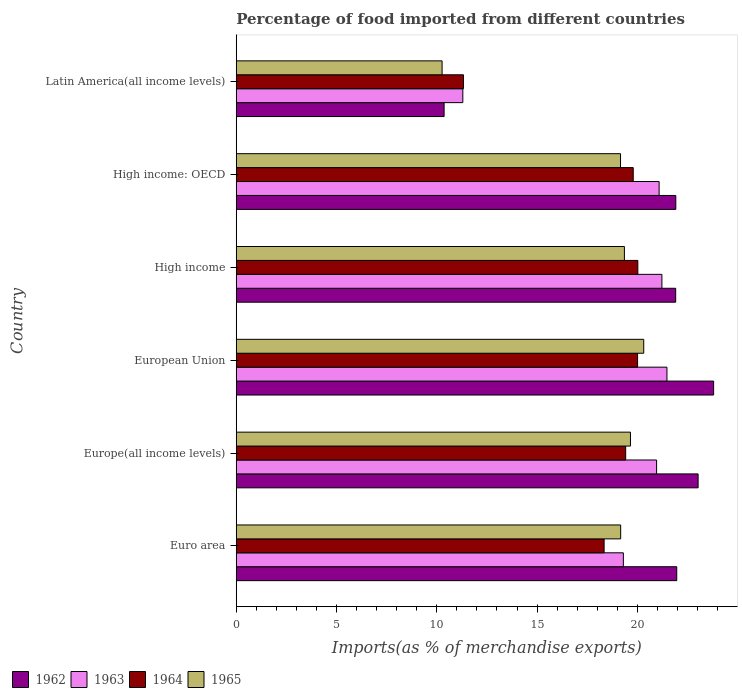How many different coloured bars are there?
Keep it short and to the point. 4. Are the number of bars per tick equal to the number of legend labels?
Make the answer very short. Yes. How many bars are there on the 2nd tick from the top?
Provide a succinct answer. 4. What is the label of the 3rd group of bars from the top?
Your response must be concise. High income. What is the percentage of imports to different countries in 1964 in Euro area?
Offer a very short reply. 18.34. Across all countries, what is the maximum percentage of imports to different countries in 1964?
Your answer should be compact. 20.02. Across all countries, what is the minimum percentage of imports to different countries in 1962?
Your answer should be very brief. 10.36. In which country was the percentage of imports to different countries in 1964 minimum?
Your answer should be very brief. Latin America(all income levels). What is the total percentage of imports to different countries in 1962 in the graph?
Provide a succinct answer. 123. What is the difference between the percentage of imports to different countries in 1965 in Europe(all income levels) and that in High income?
Your answer should be very brief. 0.3. What is the difference between the percentage of imports to different countries in 1963 in Euro area and the percentage of imports to different countries in 1965 in European Union?
Provide a short and direct response. -1.02. What is the average percentage of imports to different countries in 1964 per country?
Ensure brevity in your answer.  18.15. What is the difference between the percentage of imports to different countries in 1964 and percentage of imports to different countries in 1962 in European Union?
Provide a succinct answer. -3.79. What is the ratio of the percentage of imports to different countries in 1962 in High income to that in High income: OECD?
Offer a very short reply. 1. Is the percentage of imports to different countries in 1963 in Europe(all income levels) less than that in High income?
Offer a terse response. Yes. Is the difference between the percentage of imports to different countries in 1964 in Europe(all income levels) and European Union greater than the difference between the percentage of imports to different countries in 1962 in Europe(all income levels) and European Union?
Provide a short and direct response. Yes. What is the difference between the highest and the second highest percentage of imports to different countries in 1962?
Offer a very short reply. 0.77. What is the difference between the highest and the lowest percentage of imports to different countries in 1963?
Provide a short and direct response. 10.18. In how many countries, is the percentage of imports to different countries in 1965 greater than the average percentage of imports to different countries in 1965 taken over all countries?
Ensure brevity in your answer.  5. What does the 1st bar from the top in High income: OECD represents?
Your response must be concise. 1965. Are all the bars in the graph horizontal?
Give a very brief answer. Yes. What is the difference between two consecutive major ticks on the X-axis?
Offer a very short reply. 5. Where does the legend appear in the graph?
Provide a succinct answer. Bottom left. What is the title of the graph?
Your response must be concise. Percentage of food imported from different countries. What is the label or title of the X-axis?
Make the answer very short. Imports(as % of merchandise exports). What is the Imports(as % of merchandise exports) of 1962 in Euro area?
Your answer should be compact. 21.97. What is the Imports(as % of merchandise exports) of 1963 in Euro area?
Give a very brief answer. 19.3. What is the Imports(as % of merchandise exports) of 1964 in Euro area?
Give a very brief answer. 18.34. What is the Imports(as % of merchandise exports) in 1965 in Euro area?
Your response must be concise. 19.17. What is the Imports(as % of merchandise exports) in 1962 in Europe(all income levels)?
Offer a very short reply. 23.03. What is the Imports(as % of merchandise exports) in 1963 in Europe(all income levels)?
Give a very brief answer. 20.96. What is the Imports(as % of merchandise exports) of 1964 in Europe(all income levels)?
Offer a terse response. 19.42. What is the Imports(as % of merchandise exports) in 1965 in Europe(all income levels)?
Offer a terse response. 19.66. What is the Imports(as % of merchandise exports) in 1962 in European Union?
Ensure brevity in your answer.  23.8. What is the Imports(as % of merchandise exports) in 1963 in European Union?
Give a very brief answer. 21.48. What is the Imports(as % of merchandise exports) in 1964 in European Union?
Provide a short and direct response. 20.01. What is the Imports(as % of merchandise exports) of 1965 in European Union?
Provide a succinct answer. 20.32. What is the Imports(as % of merchandise exports) of 1962 in High income?
Provide a succinct answer. 21.91. What is the Imports(as % of merchandise exports) in 1963 in High income?
Offer a very short reply. 21.23. What is the Imports(as % of merchandise exports) of 1964 in High income?
Keep it short and to the point. 20.02. What is the Imports(as % of merchandise exports) in 1965 in High income?
Offer a terse response. 19.36. What is the Imports(as % of merchandise exports) of 1962 in High income: OECD?
Offer a terse response. 21.92. What is the Imports(as % of merchandise exports) in 1963 in High income: OECD?
Your answer should be very brief. 21.09. What is the Imports(as % of merchandise exports) of 1964 in High income: OECD?
Provide a short and direct response. 19.8. What is the Imports(as % of merchandise exports) in 1965 in High income: OECD?
Make the answer very short. 19.16. What is the Imports(as % of merchandise exports) in 1962 in Latin America(all income levels)?
Provide a succinct answer. 10.36. What is the Imports(as % of merchandise exports) in 1963 in Latin America(all income levels)?
Your answer should be very brief. 11.3. What is the Imports(as % of merchandise exports) of 1964 in Latin America(all income levels)?
Keep it short and to the point. 11.33. What is the Imports(as % of merchandise exports) in 1965 in Latin America(all income levels)?
Offer a very short reply. 10.26. Across all countries, what is the maximum Imports(as % of merchandise exports) of 1962?
Provide a short and direct response. 23.8. Across all countries, what is the maximum Imports(as % of merchandise exports) of 1963?
Ensure brevity in your answer.  21.48. Across all countries, what is the maximum Imports(as % of merchandise exports) of 1964?
Give a very brief answer. 20.02. Across all countries, what is the maximum Imports(as % of merchandise exports) in 1965?
Keep it short and to the point. 20.32. Across all countries, what is the minimum Imports(as % of merchandise exports) of 1962?
Provide a succinct answer. 10.36. Across all countries, what is the minimum Imports(as % of merchandise exports) in 1963?
Offer a terse response. 11.3. Across all countries, what is the minimum Imports(as % of merchandise exports) in 1964?
Offer a terse response. 11.33. Across all countries, what is the minimum Imports(as % of merchandise exports) of 1965?
Offer a very short reply. 10.26. What is the total Imports(as % of merchandise exports) in 1962 in the graph?
Provide a short and direct response. 123. What is the total Imports(as % of merchandise exports) in 1963 in the graph?
Make the answer very short. 115.35. What is the total Imports(as % of merchandise exports) of 1964 in the graph?
Provide a short and direct response. 108.92. What is the total Imports(as % of merchandise exports) of 1965 in the graph?
Offer a terse response. 107.93. What is the difference between the Imports(as % of merchandise exports) of 1962 in Euro area and that in Europe(all income levels)?
Your answer should be very brief. -1.07. What is the difference between the Imports(as % of merchandise exports) of 1963 in Euro area and that in Europe(all income levels)?
Make the answer very short. -1.66. What is the difference between the Imports(as % of merchandise exports) in 1964 in Euro area and that in Europe(all income levels)?
Make the answer very short. -1.08. What is the difference between the Imports(as % of merchandise exports) of 1965 in Euro area and that in Europe(all income levels)?
Your response must be concise. -0.49. What is the difference between the Imports(as % of merchandise exports) in 1962 in Euro area and that in European Union?
Your response must be concise. -1.84. What is the difference between the Imports(as % of merchandise exports) in 1963 in Euro area and that in European Union?
Offer a terse response. -2.17. What is the difference between the Imports(as % of merchandise exports) of 1964 in Euro area and that in European Union?
Your answer should be very brief. -1.67. What is the difference between the Imports(as % of merchandise exports) of 1965 in Euro area and that in European Union?
Your answer should be compact. -1.15. What is the difference between the Imports(as % of merchandise exports) of 1962 in Euro area and that in High income?
Provide a short and direct response. 0.05. What is the difference between the Imports(as % of merchandise exports) in 1963 in Euro area and that in High income?
Keep it short and to the point. -1.92. What is the difference between the Imports(as % of merchandise exports) of 1964 in Euro area and that in High income?
Offer a very short reply. -1.68. What is the difference between the Imports(as % of merchandise exports) in 1965 in Euro area and that in High income?
Offer a very short reply. -0.19. What is the difference between the Imports(as % of merchandise exports) in 1962 in Euro area and that in High income: OECD?
Offer a very short reply. 0.05. What is the difference between the Imports(as % of merchandise exports) in 1963 in Euro area and that in High income: OECD?
Give a very brief answer. -1.78. What is the difference between the Imports(as % of merchandise exports) of 1964 in Euro area and that in High income: OECD?
Offer a terse response. -1.45. What is the difference between the Imports(as % of merchandise exports) in 1965 in Euro area and that in High income: OECD?
Your response must be concise. 0.01. What is the difference between the Imports(as % of merchandise exports) of 1962 in Euro area and that in Latin America(all income levels)?
Offer a terse response. 11.6. What is the difference between the Imports(as % of merchandise exports) in 1963 in Euro area and that in Latin America(all income levels)?
Your answer should be very brief. 8. What is the difference between the Imports(as % of merchandise exports) of 1964 in Euro area and that in Latin America(all income levels)?
Provide a short and direct response. 7.01. What is the difference between the Imports(as % of merchandise exports) of 1965 in Euro area and that in Latin America(all income levels)?
Your answer should be very brief. 8.9. What is the difference between the Imports(as % of merchandise exports) of 1962 in Europe(all income levels) and that in European Union?
Your answer should be compact. -0.77. What is the difference between the Imports(as % of merchandise exports) in 1963 in Europe(all income levels) and that in European Union?
Provide a short and direct response. -0.52. What is the difference between the Imports(as % of merchandise exports) of 1964 in Europe(all income levels) and that in European Union?
Give a very brief answer. -0.59. What is the difference between the Imports(as % of merchandise exports) in 1965 in Europe(all income levels) and that in European Union?
Offer a terse response. -0.66. What is the difference between the Imports(as % of merchandise exports) in 1962 in Europe(all income levels) and that in High income?
Your response must be concise. 1.12. What is the difference between the Imports(as % of merchandise exports) in 1963 in Europe(all income levels) and that in High income?
Offer a terse response. -0.27. What is the difference between the Imports(as % of merchandise exports) in 1964 in Europe(all income levels) and that in High income?
Make the answer very short. -0.61. What is the difference between the Imports(as % of merchandise exports) of 1965 in Europe(all income levels) and that in High income?
Your response must be concise. 0.3. What is the difference between the Imports(as % of merchandise exports) of 1962 in Europe(all income levels) and that in High income: OECD?
Offer a terse response. 1.11. What is the difference between the Imports(as % of merchandise exports) in 1963 in Europe(all income levels) and that in High income: OECD?
Provide a succinct answer. -0.13. What is the difference between the Imports(as % of merchandise exports) of 1964 in Europe(all income levels) and that in High income: OECD?
Provide a succinct answer. -0.38. What is the difference between the Imports(as % of merchandise exports) of 1965 in Europe(all income levels) and that in High income: OECD?
Provide a succinct answer. 0.5. What is the difference between the Imports(as % of merchandise exports) of 1962 in Europe(all income levels) and that in Latin America(all income levels)?
Your answer should be very brief. 12.67. What is the difference between the Imports(as % of merchandise exports) in 1963 in Europe(all income levels) and that in Latin America(all income levels)?
Provide a succinct answer. 9.66. What is the difference between the Imports(as % of merchandise exports) in 1964 in Europe(all income levels) and that in Latin America(all income levels)?
Give a very brief answer. 8.09. What is the difference between the Imports(as % of merchandise exports) in 1965 in Europe(all income levels) and that in Latin America(all income levels)?
Keep it short and to the point. 9.39. What is the difference between the Imports(as % of merchandise exports) of 1962 in European Union and that in High income?
Ensure brevity in your answer.  1.89. What is the difference between the Imports(as % of merchandise exports) in 1963 in European Union and that in High income?
Your response must be concise. 0.25. What is the difference between the Imports(as % of merchandise exports) of 1964 in European Union and that in High income?
Make the answer very short. -0.01. What is the difference between the Imports(as % of merchandise exports) in 1965 in European Union and that in High income?
Your answer should be very brief. 0.96. What is the difference between the Imports(as % of merchandise exports) in 1962 in European Union and that in High income: OECD?
Give a very brief answer. 1.89. What is the difference between the Imports(as % of merchandise exports) in 1963 in European Union and that in High income: OECD?
Ensure brevity in your answer.  0.39. What is the difference between the Imports(as % of merchandise exports) in 1964 in European Union and that in High income: OECD?
Give a very brief answer. 0.22. What is the difference between the Imports(as % of merchandise exports) of 1965 in European Union and that in High income: OECD?
Keep it short and to the point. 1.16. What is the difference between the Imports(as % of merchandise exports) of 1962 in European Union and that in Latin America(all income levels)?
Your answer should be very brief. 13.44. What is the difference between the Imports(as % of merchandise exports) of 1963 in European Union and that in Latin America(all income levels)?
Keep it short and to the point. 10.18. What is the difference between the Imports(as % of merchandise exports) in 1964 in European Union and that in Latin America(all income levels)?
Keep it short and to the point. 8.68. What is the difference between the Imports(as % of merchandise exports) in 1965 in European Union and that in Latin America(all income levels)?
Offer a terse response. 10.05. What is the difference between the Imports(as % of merchandise exports) in 1962 in High income and that in High income: OECD?
Offer a terse response. -0.01. What is the difference between the Imports(as % of merchandise exports) of 1963 in High income and that in High income: OECD?
Your answer should be compact. 0.14. What is the difference between the Imports(as % of merchandise exports) in 1964 in High income and that in High income: OECD?
Give a very brief answer. 0.23. What is the difference between the Imports(as % of merchandise exports) in 1965 in High income and that in High income: OECD?
Provide a short and direct response. 0.19. What is the difference between the Imports(as % of merchandise exports) in 1962 in High income and that in Latin America(all income levels)?
Your answer should be compact. 11.55. What is the difference between the Imports(as % of merchandise exports) of 1963 in High income and that in Latin America(all income levels)?
Your response must be concise. 9.93. What is the difference between the Imports(as % of merchandise exports) of 1964 in High income and that in Latin America(all income levels)?
Provide a short and direct response. 8.7. What is the difference between the Imports(as % of merchandise exports) in 1965 in High income and that in Latin America(all income levels)?
Give a very brief answer. 9.09. What is the difference between the Imports(as % of merchandise exports) in 1962 in High income: OECD and that in Latin America(all income levels)?
Your answer should be compact. 11.55. What is the difference between the Imports(as % of merchandise exports) of 1963 in High income: OECD and that in Latin America(all income levels)?
Your answer should be compact. 9.79. What is the difference between the Imports(as % of merchandise exports) of 1964 in High income: OECD and that in Latin America(all income levels)?
Offer a very short reply. 8.47. What is the difference between the Imports(as % of merchandise exports) in 1965 in High income: OECD and that in Latin America(all income levels)?
Offer a very short reply. 8.9. What is the difference between the Imports(as % of merchandise exports) of 1962 in Euro area and the Imports(as % of merchandise exports) of 1963 in Europe(all income levels)?
Make the answer very short. 1.01. What is the difference between the Imports(as % of merchandise exports) in 1962 in Euro area and the Imports(as % of merchandise exports) in 1964 in Europe(all income levels)?
Offer a very short reply. 2.55. What is the difference between the Imports(as % of merchandise exports) in 1962 in Euro area and the Imports(as % of merchandise exports) in 1965 in Europe(all income levels)?
Your response must be concise. 2.31. What is the difference between the Imports(as % of merchandise exports) of 1963 in Euro area and the Imports(as % of merchandise exports) of 1964 in Europe(all income levels)?
Keep it short and to the point. -0.12. What is the difference between the Imports(as % of merchandise exports) of 1963 in Euro area and the Imports(as % of merchandise exports) of 1965 in Europe(all income levels)?
Your answer should be very brief. -0.35. What is the difference between the Imports(as % of merchandise exports) of 1964 in Euro area and the Imports(as % of merchandise exports) of 1965 in Europe(all income levels)?
Ensure brevity in your answer.  -1.31. What is the difference between the Imports(as % of merchandise exports) of 1962 in Euro area and the Imports(as % of merchandise exports) of 1963 in European Union?
Keep it short and to the point. 0.49. What is the difference between the Imports(as % of merchandise exports) in 1962 in Euro area and the Imports(as % of merchandise exports) in 1964 in European Union?
Ensure brevity in your answer.  1.95. What is the difference between the Imports(as % of merchandise exports) in 1962 in Euro area and the Imports(as % of merchandise exports) in 1965 in European Union?
Your answer should be very brief. 1.65. What is the difference between the Imports(as % of merchandise exports) of 1963 in Euro area and the Imports(as % of merchandise exports) of 1964 in European Union?
Your answer should be very brief. -0.71. What is the difference between the Imports(as % of merchandise exports) of 1963 in Euro area and the Imports(as % of merchandise exports) of 1965 in European Union?
Offer a very short reply. -1.02. What is the difference between the Imports(as % of merchandise exports) of 1964 in Euro area and the Imports(as % of merchandise exports) of 1965 in European Union?
Your response must be concise. -1.98. What is the difference between the Imports(as % of merchandise exports) of 1962 in Euro area and the Imports(as % of merchandise exports) of 1963 in High income?
Ensure brevity in your answer.  0.74. What is the difference between the Imports(as % of merchandise exports) of 1962 in Euro area and the Imports(as % of merchandise exports) of 1964 in High income?
Offer a terse response. 1.94. What is the difference between the Imports(as % of merchandise exports) in 1962 in Euro area and the Imports(as % of merchandise exports) in 1965 in High income?
Offer a terse response. 2.61. What is the difference between the Imports(as % of merchandise exports) in 1963 in Euro area and the Imports(as % of merchandise exports) in 1964 in High income?
Your answer should be very brief. -0.72. What is the difference between the Imports(as % of merchandise exports) of 1963 in Euro area and the Imports(as % of merchandise exports) of 1965 in High income?
Keep it short and to the point. -0.05. What is the difference between the Imports(as % of merchandise exports) in 1964 in Euro area and the Imports(as % of merchandise exports) in 1965 in High income?
Make the answer very short. -1.01. What is the difference between the Imports(as % of merchandise exports) in 1962 in Euro area and the Imports(as % of merchandise exports) in 1963 in High income: OECD?
Give a very brief answer. 0.88. What is the difference between the Imports(as % of merchandise exports) of 1962 in Euro area and the Imports(as % of merchandise exports) of 1964 in High income: OECD?
Offer a terse response. 2.17. What is the difference between the Imports(as % of merchandise exports) of 1962 in Euro area and the Imports(as % of merchandise exports) of 1965 in High income: OECD?
Offer a terse response. 2.8. What is the difference between the Imports(as % of merchandise exports) in 1963 in Euro area and the Imports(as % of merchandise exports) in 1964 in High income: OECD?
Offer a very short reply. -0.49. What is the difference between the Imports(as % of merchandise exports) in 1963 in Euro area and the Imports(as % of merchandise exports) in 1965 in High income: OECD?
Your response must be concise. 0.14. What is the difference between the Imports(as % of merchandise exports) of 1964 in Euro area and the Imports(as % of merchandise exports) of 1965 in High income: OECD?
Your answer should be very brief. -0.82. What is the difference between the Imports(as % of merchandise exports) of 1962 in Euro area and the Imports(as % of merchandise exports) of 1963 in Latin America(all income levels)?
Provide a short and direct response. 10.67. What is the difference between the Imports(as % of merchandise exports) in 1962 in Euro area and the Imports(as % of merchandise exports) in 1964 in Latin America(all income levels)?
Provide a short and direct response. 10.64. What is the difference between the Imports(as % of merchandise exports) in 1962 in Euro area and the Imports(as % of merchandise exports) in 1965 in Latin America(all income levels)?
Make the answer very short. 11.7. What is the difference between the Imports(as % of merchandise exports) of 1963 in Euro area and the Imports(as % of merchandise exports) of 1964 in Latin America(all income levels)?
Keep it short and to the point. 7.97. What is the difference between the Imports(as % of merchandise exports) in 1963 in Euro area and the Imports(as % of merchandise exports) in 1965 in Latin America(all income levels)?
Provide a succinct answer. 9.04. What is the difference between the Imports(as % of merchandise exports) in 1964 in Euro area and the Imports(as % of merchandise exports) in 1965 in Latin America(all income levels)?
Your response must be concise. 8.08. What is the difference between the Imports(as % of merchandise exports) of 1962 in Europe(all income levels) and the Imports(as % of merchandise exports) of 1963 in European Union?
Offer a terse response. 1.55. What is the difference between the Imports(as % of merchandise exports) in 1962 in Europe(all income levels) and the Imports(as % of merchandise exports) in 1964 in European Union?
Ensure brevity in your answer.  3.02. What is the difference between the Imports(as % of merchandise exports) of 1962 in Europe(all income levels) and the Imports(as % of merchandise exports) of 1965 in European Union?
Make the answer very short. 2.71. What is the difference between the Imports(as % of merchandise exports) in 1963 in Europe(all income levels) and the Imports(as % of merchandise exports) in 1964 in European Union?
Offer a very short reply. 0.95. What is the difference between the Imports(as % of merchandise exports) in 1963 in Europe(all income levels) and the Imports(as % of merchandise exports) in 1965 in European Union?
Offer a terse response. 0.64. What is the difference between the Imports(as % of merchandise exports) in 1964 in Europe(all income levels) and the Imports(as % of merchandise exports) in 1965 in European Union?
Provide a short and direct response. -0.9. What is the difference between the Imports(as % of merchandise exports) in 1962 in Europe(all income levels) and the Imports(as % of merchandise exports) in 1963 in High income?
Provide a short and direct response. 1.81. What is the difference between the Imports(as % of merchandise exports) of 1962 in Europe(all income levels) and the Imports(as % of merchandise exports) of 1964 in High income?
Your response must be concise. 3.01. What is the difference between the Imports(as % of merchandise exports) of 1962 in Europe(all income levels) and the Imports(as % of merchandise exports) of 1965 in High income?
Ensure brevity in your answer.  3.68. What is the difference between the Imports(as % of merchandise exports) of 1963 in Europe(all income levels) and the Imports(as % of merchandise exports) of 1964 in High income?
Your answer should be very brief. 0.94. What is the difference between the Imports(as % of merchandise exports) of 1963 in Europe(all income levels) and the Imports(as % of merchandise exports) of 1965 in High income?
Your answer should be compact. 1.61. What is the difference between the Imports(as % of merchandise exports) of 1964 in Europe(all income levels) and the Imports(as % of merchandise exports) of 1965 in High income?
Provide a succinct answer. 0.06. What is the difference between the Imports(as % of merchandise exports) of 1962 in Europe(all income levels) and the Imports(as % of merchandise exports) of 1963 in High income: OECD?
Your answer should be very brief. 1.94. What is the difference between the Imports(as % of merchandise exports) of 1962 in Europe(all income levels) and the Imports(as % of merchandise exports) of 1964 in High income: OECD?
Offer a very short reply. 3.24. What is the difference between the Imports(as % of merchandise exports) of 1962 in Europe(all income levels) and the Imports(as % of merchandise exports) of 1965 in High income: OECD?
Offer a terse response. 3.87. What is the difference between the Imports(as % of merchandise exports) of 1963 in Europe(all income levels) and the Imports(as % of merchandise exports) of 1964 in High income: OECD?
Your answer should be very brief. 1.16. What is the difference between the Imports(as % of merchandise exports) of 1963 in Europe(all income levels) and the Imports(as % of merchandise exports) of 1965 in High income: OECD?
Provide a succinct answer. 1.8. What is the difference between the Imports(as % of merchandise exports) of 1964 in Europe(all income levels) and the Imports(as % of merchandise exports) of 1965 in High income: OECD?
Provide a short and direct response. 0.26. What is the difference between the Imports(as % of merchandise exports) in 1962 in Europe(all income levels) and the Imports(as % of merchandise exports) in 1963 in Latin America(all income levels)?
Offer a very short reply. 11.73. What is the difference between the Imports(as % of merchandise exports) of 1962 in Europe(all income levels) and the Imports(as % of merchandise exports) of 1964 in Latin America(all income levels)?
Offer a terse response. 11.7. What is the difference between the Imports(as % of merchandise exports) in 1962 in Europe(all income levels) and the Imports(as % of merchandise exports) in 1965 in Latin America(all income levels)?
Your answer should be very brief. 12.77. What is the difference between the Imports(as % of merchandise exports) in 1963 in Europe(all income levels) and the Imports(as % of merchandise exports) in 1964 in Latin America(all income levels)?
Your answer should be very brief. 9.63. What is the difference between the Imports(as % of merchandise exports) in 1963 in Europe(all income levels) and the Imports(as % of merchandise exports) in 1965 in Latin America(all income levels)?
Your answer should be very brief. 10.7. What is the difference between the Imports(as % of merchandise exports) in 1964 in Europe(all income levels) and the Imports(as % of merchandise exports) in 1965 in Latin America(all income levels)?
Provide a succinct answer. 9.15. What is the difference between the Imports(as % of merchandise exports) in 1962 in European Union and the Imports(as % of merchandise exports) in 1963 in High income?
Your response must be concise. 2.58. What is the difference between the Imports(as % of merchandise exports) of 1962 in European Union and the Imports(as % of merchandise exports) of 1964 in High income?
Give a very brief answer. 3.78. What is the difference between the Imports(as % of merchandise exports) in 1962 in European Union and the Imports(as % of merchandise exports) in 1965 in High income?
Offer a terse response. 4.45. What is the difference between the Imports(as % of merchandise exports) in 1963 in European Union and the Imports(as % of merchandise exports) in 1964 in High income?
Give a very brief answer. 1.45. What is the difference between the Imports(as % of merchandise exports) of 1963 in European Union and the Imports(as % of merchandise exports) of 1965 in High income?
Provide a succinct answer. 2.12. What is the difference between the Imports(as % of merchandise exports) of 1964 in European Union and the Imports(as % of merchandise exports) of 1965 in High income?
Your answer should be compact. 0.66. What is the difference between the Imports(as % of merchandise exports) in 1962 in European Union and the Imports(as % of merchandise exports) in 1963 in High income: OECD?
Your answer should be very brief. 2.72. What is the difference between the Imports(as % of merchandise exports) of 1962 in European Union and the Imports(as % of merchandise exports) of 1964 in High income: OECD?
Offer a terse response. 4.01. What is the difference between the Imports(as % of merchandise exports) in 1962 in European Union and the Imports(as % of merchandise exports) in 1965 in High income: OECD?
Your response must be concise. 4.64. What is the difference between the Imports(as % of merchandise exports) of 1963 in European Union and the Imports(as % of merchandise exports) of 1964 in High income: OECD?
Make the answer very short. 1.68. What is the difference between the Imports(as % of merchandise exports) of 1963 in European Union and the Imports(as % of merchandise exports) of 1965 in High income: OECD?
Your answer should be compact. 2.32. What is the difference between the Imports(as % of merchandise exports) of 1964 in European Union and the Imports(as % of merchandise exports) of 1965 in High income: OECD?
Offer a very short reply. 0.85. What is the difference between the Imports(as % of merchandise exports) of 1962 in European Union and the Imports(as % of merchandise exports) of 1963 in Latin America(all income levels)?
Your response must be concise. 12.51. What is the difference between the Imports(as % of merchandise exports) in 1962 in European Union and the Imports(as % of merchandise exports) in 1964 in Latin America(all income levels)?
Provide a succinct answer. 12.47. What is the difference between the Imports(as % of merchandise exports) of 1962 in European Union and the Imports(as % of merchandise exports) of 1965 in Latin America(all income levels)?
Your answer should be very brief. 13.54. What is the difference between the Imports(as % of merchandise exports) of 1963 in European Union and the Imports(as % of merchandise exports) of 1964 in Latin America(all income levels)?
Keep it short and to the point. 10.15. What is the difference between the Imports(as % of merchandise exports) of 1963 in European Union and the Imports(as % of merchandise exports) of 1965 in Latin America(all income levels)?
Ensure brevity in your answer.  11.21. What is the difference between the Imports(as % of merchandise exports) of 1964 in European Union and the Imports(as % of merchandise exports) of 1965 in Latin America(all income levels)?
Give a very brief answer. 9.75. What is the difference between the Imports(as % of merchandise exports) in 1962 in High income and the Imports(as % of merchandise exports) in 1963 in High income: OECD?
Provide a short and direct response. 0.83. What is the difference between the Imports(as % of merchandise exports) of 1962 in High income and the Imports(as % of merchandise exports) of 1964 in High income: OECD?
Give a very brief answer. 2.12. What is the difference between the Imports(as % of merchandise exports) of 1962 in High income and the Imports(as % of merchandise exports) of 1965 in High income: OECD?
Keep it short and to the point. 2.75. What is the difference between the Imports(as % of merchandise exports) of 1963 in High income and the Imports(as % of merchandise exports) of 1964 in High income: OECD?
Your answer should be compact. 1.43. What is the difference between the Imports(as % of merchandise exports) of 1963 in High income and the Imports(as % of merchandise exports) of 1965 in High income: OECD?
Keep it short and to the point. 2.06. What is the difference between the Imports(as % of merchandise exports) in 1964 in High income and the Imports(as % of merchandise exports) in 1965 in High income: OECD?
Keep it short and to the point. 0.86. What is the difference between the Imports(as % of merchandise exports) of 1962 in High income and the Imports(as % of merchandise exports) of 1963 in Latin America(all income levels)?
Offer a terse response. 10.61. What is the difference between the Imports(as % of merchandise exports) of 1962 in High income and the Imports(as % of merchandise exports) of 1964 in Latin America(all income levels)?
Your answer should be compact. 10.58. What is the difference between the Imports(as % of merchandise exports) of 1962 in High income and the Imports(as % of merchandise exports) of 1965 in Latin America(all income levels)?
Keep it short and to the point. 11.65. What is the difference between the Imports(as % of merchandise exports) of 1963 in High income and the Imports(as % of merchandise exports) of 1964 in Latin America(all income levels)?
Provide a short and direct response. 9.9. What is the difference between the Imports(as % of merchandise exports) of 1963 in High income and the Imports(as % of merchandise exports) of 1965 in Latin America(all income levels)?
Provide a short and direct response. 10.96. What is the difference between the Imports(as % of merchandise exports) of 1964 in High income and the Imports(as % of merchandise exports) of 1965 in Latin America(all income levels)?
Your answer should be very brief. 9.76. What is the difference between the Imports(as % of merchandise exports) in 1962 in High income: OECD and the Imports(as % of merchandise exports) in 1963 in Latin America(all income levels)?
Offer a very short reply. 10.62. What is the difference between the Imports(as % of merchandise exports) in 1962 in High income: OECD and the Imports(as % of merchandise exports) in 1964 in Latin America(all income levels)?
Your answer should be compact. 10.59. What is the difference between the Imports(as % of merchandise exports) of 1962 in High income: OECD and the Imports(as % of merchandise exports) of 1965 in Latin America(all income levels)?
Offer a very short reply. 11.65. What is the difference between the Imports(as % of merchandise exports) of 1963 in High income: OECD and the Imports(as % of merchandise exports) of 1964 in Latin America(all income levels)?
Your answer should be compact. 9.76. What is the difference between the Imports(as % of merchandise exports) of 1963 in High income: OECD and the Imports(as % of merchandise exports) of 1965 in Latin America(all income levels)?
Offer a terse response. 10.82. What is the difference between the Imports(as % of merchandise exports) of 1964 in High income: OECD and the Imports(as % of merchandise exports) of 1965 in Latin America(all income levels)?
Your answer should be compact. 9.53. What is the average Imports(as % of merchandise exports) of 1962 per country?
Your answer should be very brief. 20.5. What is the average Imports(as % of merchandise exports) in 1963 per country?
Make the answer very short. 19.23. What is the average Imports(as % of merchandise exports) in 1964 per country?
Keep it short and to the point. 18.15. What is the average Imports(as % of merchandise exports) of 1965 per country?
Offer a very short reply. 17.99. What is the difference between the Imports(as % of merchandise exports) of 1962 and Imports(as % of merchandise exports) of 1963 in Euro area?
Offer a terse response. 2.66. What is the difference between the Imports(as % of merchandise exports) of 1962 and Imports(as % of merchandise exports) of 1964 in Euro area?
Provide a short and direct response. 3.62. What is the difference between the Imports(as % of merchandise exports) of 1962 and Imports(as % of merchandise exports) of 1965 in Euro area?
Keep it short and to the point. 2.8. What is the difference between the Imports(as % of merchandise exports) in 1963 and Imports(as % of merchandise exports) in 1964 in Euro area?
Your answer should be very brief. 0.96. What is the difference between the Imports(as % of merchandise exports) of 1963 and Imports(as % of merchandise exports) of 1965 in Euro area?
Provide a short and direct response. 0.13. What is the difference between the Imports(as % of merchandise exports) in 1964 and Imports(as % of merchandise exports) in 1965 in Euro area?
Ensure brevity in your answer.  -0.83. What is the difference between the Imports(as % of merchandise exports) in 1962 and Imports(as % of merchandise exports) in 1963 in Europe(all income levels)?
Provide a succinct answer. 2.07. What is the difference between the Imports(as % of merchandise exports) in 1962 and Imports(as % of merchandise exports) in 1964 in Europe(all income levels)?
Provide a succinct answer. 3.61. What is the difference between the Imports(as % of merchandise exports) of 1962 and Imports(as % of merchandise exports) of 1965 in Europe(all income levels)?
Keep it short and to the point. 3.37. What is the difference between the Imports(as % of merchandise exports) in 1963 and Imports(as % of merchandise exports) in 1964 in Europe(all income levels)?
Provide a succinct answer. 1.54. What is the difference between the Imports(as % of merchandise exports) of 1963 and Imports(as % of merchandise exports) of 1965 in Europe(all income levels)?
Offer a very short reply. 1.3. What is the difference between the Imports(as % of merchandise exports) of 1964 and Imports(as % of merchandise exports) of 1965 in Europe(all income levels)?
Keep it short and to the point. -0.24. What is the difference between the Imports(as % of merchandise exports) in 1962 and Imports(as % of merchandise exports) in 1963 in European Union?
Keep it short and to the point. 2.33. What is the difference between the Imports(as % of merchandise exports) of 1962 and Imports(as % of merchandise exports) of 1964 in European Union?
Keep it short and to the point. 3.79. What is the difference between the Imports(as % of merchandise exports) in 1962 and Imports(as % of merchandise exports) in 1965 in European Union?
Provide a short and direct response. 3.49. What is the difference between the Imports(as % of merchandise exports) of 1963 and Imports(as % of merchandise exports) of 1964 in European Union?
Your answer should be very brief. 1.46. What is the difference between the Imports(as % of merchandise exports) in 1963 and Imports(as % of merchandise exports) in 1965 in European Union?
Provide a succinct answer. 1.16. What is the difference between the Imports(as % of merchandise exports) in 1964 and Imports(as % of merchandise exports) in 1965 in European Union?
Give a very brief answer. -0.31. What is the difference between the Imports(as % of merchandise exports) in 1962 and Imports(as % of merchandise exports) in 1963 in High income?
Make the answer very short. 0.69. What is the difference between the Imports(as % of merchandise exports) in 1962 and Imports(as % of merchandise exports) in 1964 in High income?
Ensure brevity in your answer.  1.89. What is the difference between the Imports(as % of merchandise exports) in 1962 and Imports(as % of merchandise exports) in 1965 in High income?
Your answer should be very brief. 2.56. What is the difference between the Imports(as % of merchandise exports) of 1963 and Imports(as % of merchandise exports) of 1964 in High income?
Make the answer very short. 1.2. What is the difference between the Imports(as % of merchandise exports) in 1963 and Imports(as % of merchandise exports) in 1965 in High income?
Your answer should be very brief. 1.87. What is the difference between the Imports(as % of merchandise exports) in 1964 and Imports(as % of merchandise exports) in 1965 in High income?
Keep it short and to the point. 0.67. What is the difference between the Imports(as % of merchandise exports) of 1962 and Imports(as % of merchandise exports) of 1963 in High income: OECD?
Ensure brevity in your answer.  0.83. What is the difference between the Imports(as % of merchandise exports) in 1962 and Imports(as % of merchandise exports) in 1964 in High income: OECD?
Make the answer very short. 2.12. What is the difference between the Imports(as % of merchandise exports) of 1962 and Imports(as % of merchandise exports) of 1965 in High income: OECD?
Your answer should be very brief. 2.76. What is the difference between the Imports(as % of merchandise exports) of 1963 and Imports(as % of merchandise exports) of 1964 in High income: OECD?
Provide a succinct answer. 1.29. What is the difference between the Imports(as % of merchandise exports) of 1963 and Imports(as % of merchandise exports) of 1965 in High income: OECD?
Keep it short and to the point. 1.93. What is the difference between the Imports(as % of merchandise exports) in 1964 and Imports(as % of merchandise exports) in 1965 in High income: OECD?
Your answer should be very brief. 0.63. What is the difference between the Imports(as % of merchandise exports) of 1962 and Imports(as % of merchandise exports) of 1963 in Latin America(all income levels)?
Provide a short and direct response. -0.93. What is the difference between the Imports(as % of merchandise exports) in 1962 and Imports(as % of merchandise exports) in 1964 in Latin America(all income levels)?
Provide a short and direct response. -0.96. What is the difference between the Imports(as % of merchandise exports) of 1962 and Imports(as % of merchandise exports) of 1965 in Latin America(all income levels)?
Provide a succinct answer. 0.1. What is the difference between the Imports(as % of merchandise exports) of 1963 and Imports(as % of merchandise exports) of 1964 in Latin America(all income levels)?
Your answer should be very brief. -0.03. What is the difference between the Imports(as % of merchandise exports) of 1963 and Imports(as % of merchandise exports) of 1965 in Latin America(all income levels)?
Your answer should be compact. 1.03. What is the difference between the Imports(as % of merchandise exports) of 1964 and Imports(as % of merchandise exports) of 1965 in Latin America(all income levels)?
Provide a short and direct response. 1.07. What is the ratio of the Imports(as % of merchandise exports) of 1962 in Euro area to that in Europe(all income levels)?
Provide a short and direct response. 0.95. What is the ratio of the Imports(as % of merchandise exports) in 1963 in Euro area to that in Europe(all income levels)?
Offer a terse response. 0.92. What is the ratio of the Imports(as % of merchandise exports) of 1964 in Euro area to that in Europe(all income levels)?
Make the answer very short. 0.94. What is the ratio of the Imports(as % of merchandise exports) of 1965 in Euro area to that in Europe(all income levels)?
Your response must be concise. 0.98. What is the ratio of the Imports(as % of merchandise exports) in 1962 in Euro area to that in European Union?
Give a very brief answer. 0.92. What is the ratio of the Imports(as % of merchandise exports) in 1963 in Euro area to that in European Union?
Your response must be concise. 0.9. What is the ratio of the Imports(as % of merchandise exports) in 1964 in Euro area to that in European Union?
Provide a short and direct response. 0.92. What is the ratio of the Imports(as % of merchandise exports) of 1965 in Euro area to that in European Union?
Make the answer very short. 0.94. What is the ratio of the Imports(as % of merchandise exports) in 1962 in Euro area to that in High income?
Offer a very short reply. 1. What is the ratio of the Imports(as % of merchandise exports) in 1963 in Euro area to that in High income?
Give a very brief answer. 0.91. What is the ratio of the Imports(as % of merchandise exports) of 1964 in Euro area to that in High income?
Provide a short and direct response. 0.92. What is the ratio of the Imports(as % of merchandise exports) in 1965 in Euro area to that in High income?
Offer a terse response. 0.99. What is the ratio of the Imports(as % of merchandise exports) of 1963 in Euro area to that in High income: OECD?
Ensure brevity in your answer.  0.92. What is the ratio of the Imports(as % of merchandise exports) in 1964 in Euro area to that in High income: OECD?
Offer a terse response. 0.93. What is the ratio of the Imports(as % of merchandise exports) in 1965 in Euro area to that in High income: OECD?
Keep it short and to the point. 1. What is the ratio of the Imports(as % of merchandise exports) of 1962 in Euro area to that in Latin America(all income levels)?
Provide a short and direct response. 2.12. What is the ratio of the Imports(as % of merchandise exports) of 1963 in Euro area to that in Latin America(all income levels)?
Give a very brief answer. 1.71. What is the ratio of the Imports(as % of merchandise exports) in 1964 in Euro area to that in Latin America(all income levels)?
Offer a terse response. 1.62. What is the ratio of the Imports(as % of merchandise exports) of 1965 in Euro area to that in Latin America(all income levels)?
Give a very brief answer. 1.87. What is the ratio of the Imports(as % of merchandise exports) of 1962 in Europe(all income levels) to that in European Union?
Provide a short and direct response. 0.97. What is the ratio of the Imports(as % of merchandise exports) in 1963 in Europe(all income levels) to that in European Union?
Ensure brevity in your answer.  0.98. What is the ratio of the Imports(as % of merchandise exports) of 1964 in Europe(all income levels) to that in European Union?
Provide a succinct answer. 0.97. What is the ratio of the Imports(as % of merchandise exports) in 1965 in Europe(all income levels) to that in European Union?
Your answer should be very brief. 0.97. What is the ratio of the Imports(as % of merchandise exports) in 1962 in Europe(all income levels) to that in High income?
Your answer should be very brief. 1.05. What is the ratio of the Imports(as % of merchandise exports) of 1963 in Europe(all income levels) to that in High income?
Provide a succinct answer. 0.99. What is the ratio of the Imports(as % of merchandise exports) of 1964 in Europe(all income levels) to that in High income?
Your answer should be compact. 0.97. What is the ratio of the Imports(as % of merchandise exports) in 1965 in Europe(all income levels) to that in High income?
Your answer should be very brief. 1.02. What is the ratio of the Imports(as % of merchandise exports) in 1962 in Europe(all income levels) to that in High income: OECD?
Your answer should be compact. 1.05. What is the ratio of the Imports(as % of merchandise exports) of 1964 in Europe(all income levels) to that in High income: OECD?
Offer a very short reply. 0.98. What is the ratio of the Imports(as % of merchandise exports) of 1965 in Europe(all income levels) to that in High income: OECD?
Offer a terse response. 1.03. What is the ratio of the Imports(as % of merchandise exports) of 1962 in Europe(all income levels) to that in Latin America(all income levels)?
Your answer should be compact. 2.22. What is the ratio of the Imports(as % of merchandise exports) of 1963 in Europe(all income levels) to that in Latin America(all income levels)?
Your answer should be compact. 1.86. What is the ratio of the Imports(as % of merchandise exports) of 1964 in Europe(all income levels) to that in Latin America(all income levels)?
Provide a succinct answer. 1.71. What is the ratio of the Imports(as % of merchandise exports) of 1965 in Europe(all income levels) to that in Latin America(all income levels)?
Your answer should be compact. 1.92. What is the ratio of the Imports(as % of merchandise exports) of 1962 in European Union to that in High income?
Your answer should be very brief. 1.09. What is the ratio of the Imports(as % of merchandise exports) of 1963 in European Union to that in High income?
Your answer should be very brief. 1.01. What is the ratio of the Imports(as % of merchandise exports) of 1965 in European Union to that in High income?
Offer a very short reply. 1.05. What is the ratio of the Imports(as % of merchandise exports) in 1962 in European Union to that in High income: OECD?
Provide a succinct answer. 1.09. What is the ratio of the Imports(as % of merchandise exports) in 1963 in European Union to that in High income: OECD?
Your answer should be compact. 1.02. What is the ratio of the Imports(as % of merchandise exports) of 1964 in European Union to that in High income: OECD?
Your answer should be compact. 1.01. What is the ratio of the Imports(as % of merchandise exports) in 1965 in European Union to that in High income: OECD?
Your answer should be compact. 1.06. What is the ratio of the Imports(as % of merchandise exports) of 1962 in European Union to that in Latin America(all income levels)?
Make the answer very short. 2.3. What is the ratio of the Imports(as % of merchandise exports) of 1963 in European Union to that in Latin America(all income levels)?
Your answer should be compact. 1.9. What is the ratio of the Imports(as % of merchandise exports) in 1964 in European Union to that in Latin America(all income levels)?
Make the answer very short. 1.77. What is the ratio of the Imports(as % of merchandise exports) in 1965 in European Union to that in Latin America(all income levels)?
Offer a terse response. 1.98. What is the ratio of the Imports(as % of merchandise exports) of 1963 in High income to that in High income: OECD?
Provide a short and direct response. 1.01. What is the ratio of the Imports(as % of merchandise exports) in 1964 in High income to that in High income: OECD?
Offer a very short reply. 1.01. What is the ratio of the Imports(as % of merchandise exports) in 1962 in High income to that in Latin America(all income levels)?
Provide a short and direct response. 2.11. What is the ratio of the Imports(as % of merchandise exports) in 1963 in High income to that in Latin America(all income levels)?
Your answer should be very brief. 1.88. What is the ratio of the Imports(as % of merchandise exports) of 1964 in High income to that in Latin America(all income levels)?
Your answer should be very brief. 1.77. What is the ratio of the Imports(as % of merchandise exports) of 1965 in High income to that in Latin America(all income levels)?
Provide a short and direct response. 1.89. What is the ratio of the Imports(as % of merchandise exports) of 1962 in High income: OECD to that in Latin America(all income levels)?
Your answer should be very brief. 2.11. What is the ratio of the Imports(as % of merchandise exports) in 1963 in High income: OECD to that in Latin America(all income levels)?
Your answer should be very brief. 1.87. What is the ratio of the Imports(as % of merchandise exports) of 1964 in High income: OECD to that in Latin America(all income levels)?
Your response must be concise. 1.75. What is the ratio of the Imports(as % of merchandise exports) of 1965 in High income: OECD to that in Latin America(all income levels)?
Provide a short and direct response. 1.87. What is the difference between the highest and the second highest Imports(as % of merchandise exports) of 1962?
Offer a terse response. 0.77. What is the difference between the highest and the second highest Imports(as % of merchandise exports) in 1963?
Your answer should be compact. 0.25. What is the difference between the highest and the second highest Imports(as % of merchandise exports) in 1964?
Your answer should be compact. 0.01. What is the difference between the highest and the second highest Imports(as % of merchandise exports) of 1965?
Your answer should be very brief. 0.66. What is the difference between the highest and the lowest Imports(as % of merchandise exports) of 1962?
Your answer should be compact. 13.44. What is the difference between the highest and the lowest Imports(as % of merchandise exports) in 1963?
Offer a terse response. 10.18. What is the difference between the highest and the lowest Imports(as % of merchandise exports) in 1964?
Offer a very short reply. 8.7. What is the difference between the highest and the lowest Imports(as % of merchandise exports) of 1965?
Your response must be concise. 10.05. 